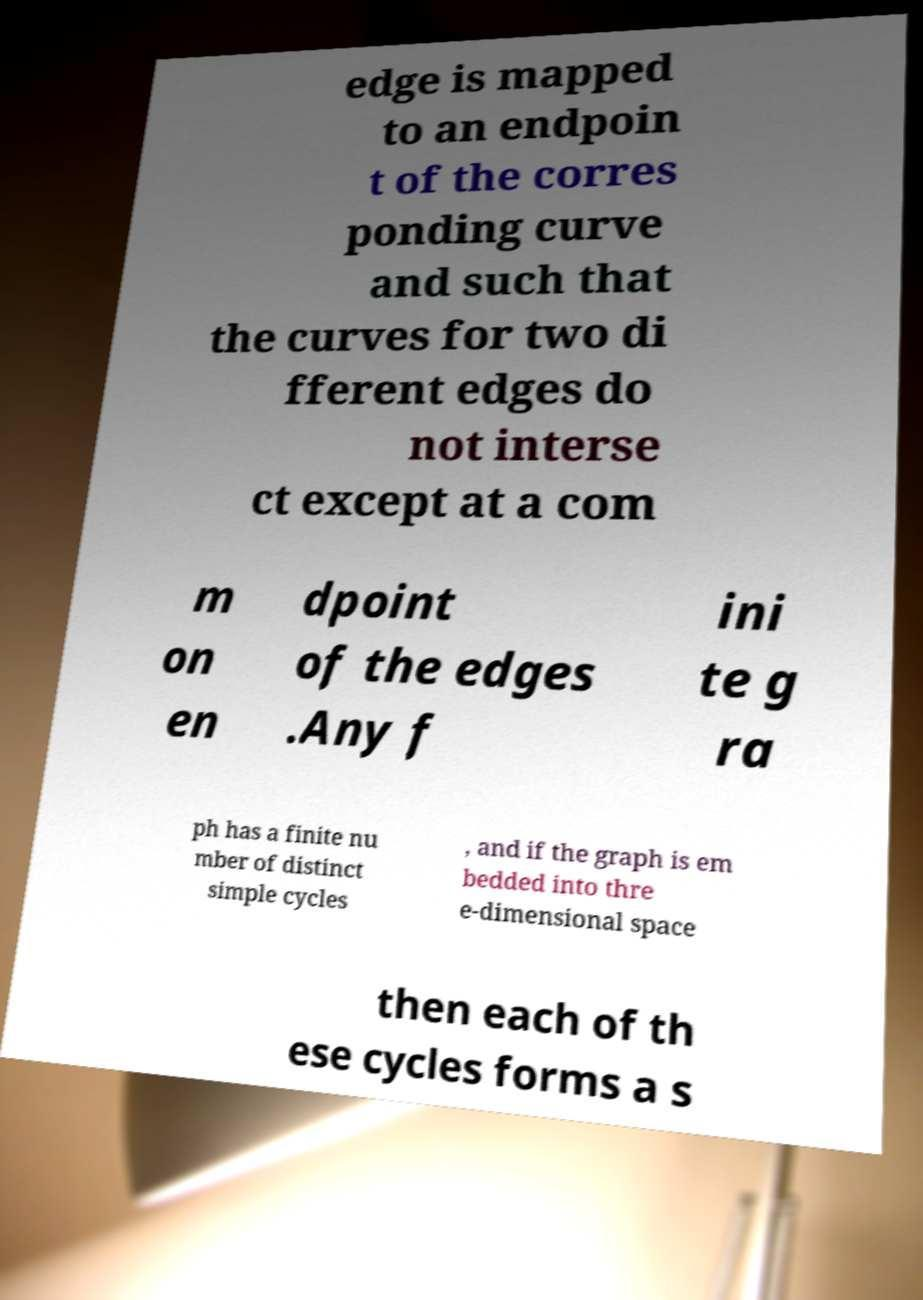Could you assist in decoding the text presented in this image and type it out clearly? edge is mapped to an endpoin t of the corres ponding curve and such that the curves for two di fferent edges do not interse ct except at a com m on en dpoint of the edges .Any f ini te g ra ph has a finite nu mber of distinct simple cycles , and if the graph is em bedded into thre e-dimensional space then each of th ese cycles forms a s 